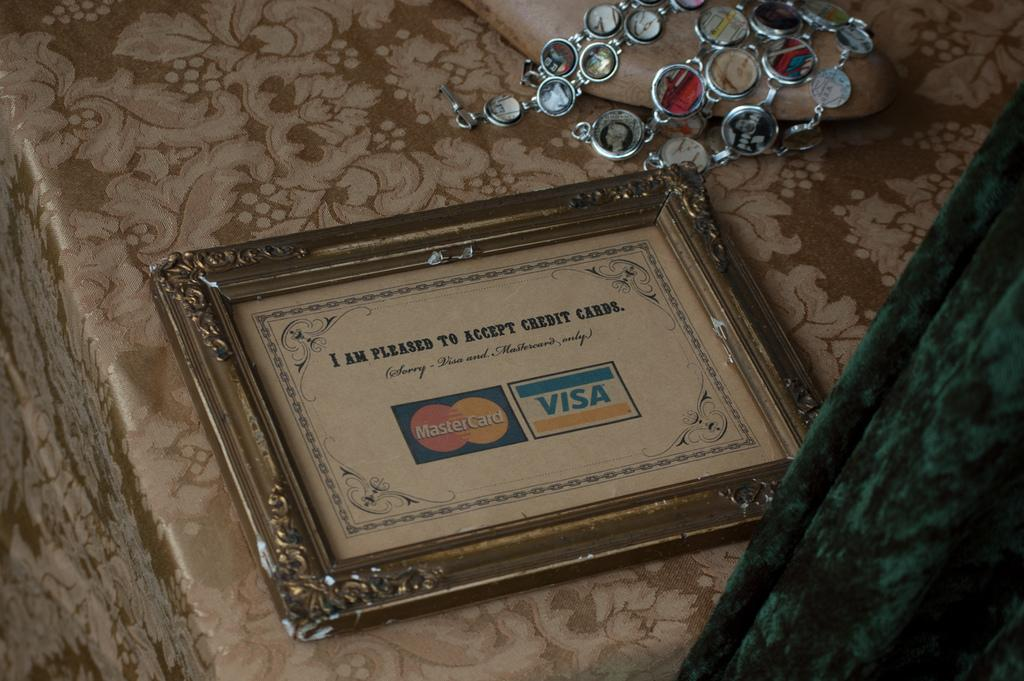Provide a one-sentence caption for the provided image. A frame with a Visa and MasterCard in it. 